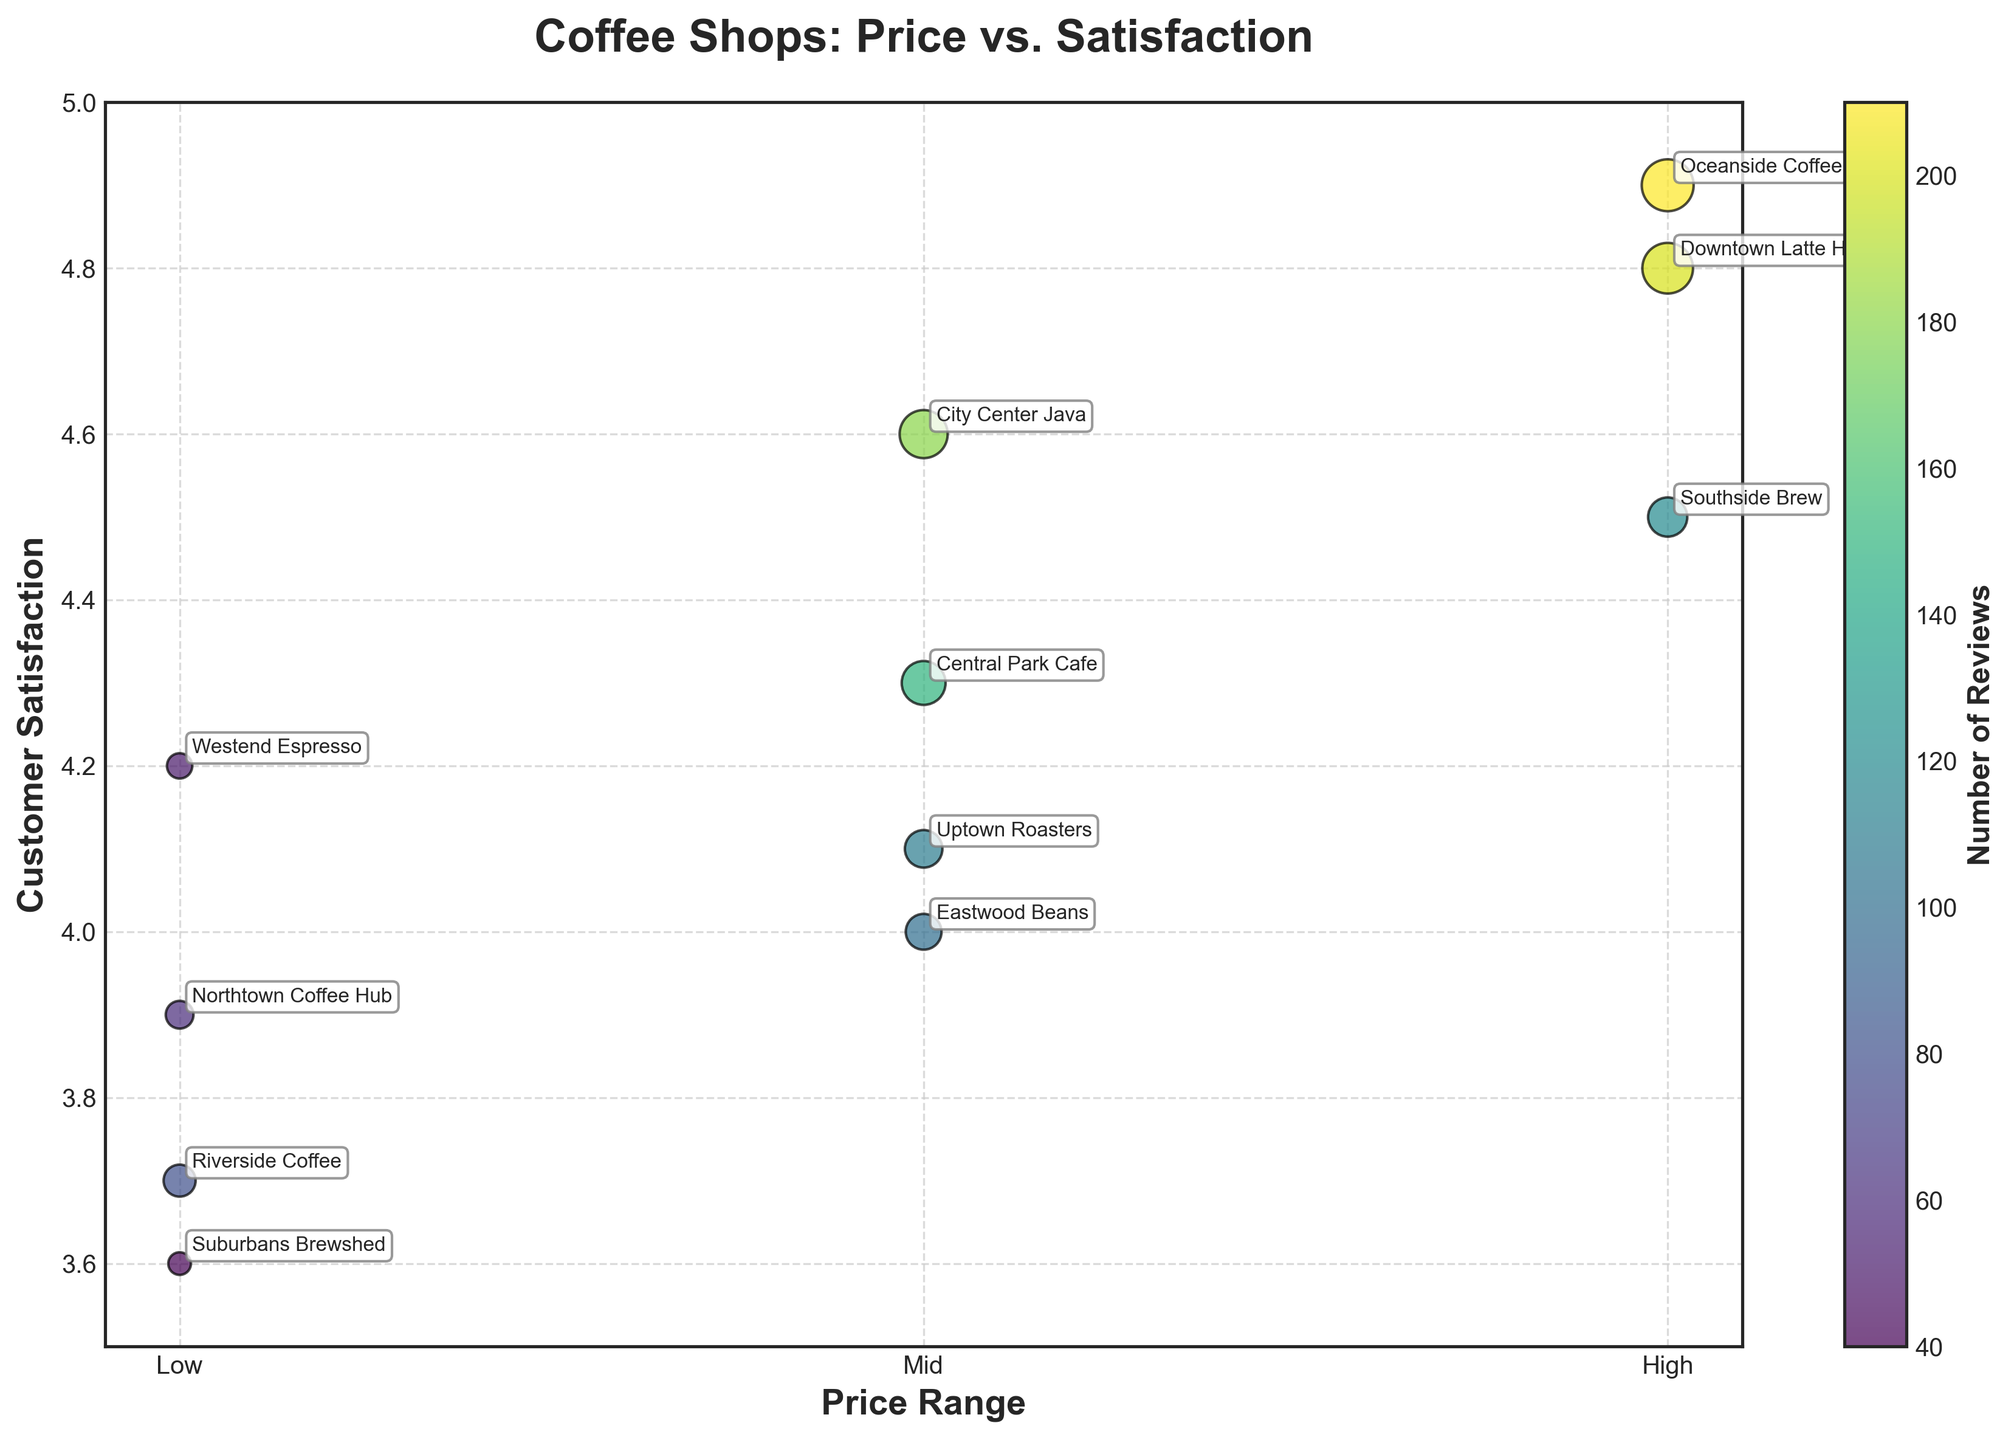What's the overall title of the figure? The overall title is located above the figure and summarizes what the figure represents. It reads "Coffee Shops: Price vs. Satisfaction".
Answer: Coffee Shops: Price vs. Satisfaction What does the x-axis label represent? The label of the x-axis is located along the horizontal axis and indicates the variable that is being measured on that axis. It represents the price range of the coffee shops.
Answer: Price Range What is the satisfaction level of 'Central Park Cafe'? Look for the bubble labeled 'Central Park Cafe' and check its position on the y-axis. The y-axis value for this point is approximately 4.3.
Answer: 4.3 Which coffee shop has the highest customer satisfaction? Identify the highest y-value on the plot and find the corresponding label. The bubble at the top of the chart is labeled 'Oceanside Coffee' with a customer satisfaction of 4.9.
Answer: Oceanside Coffee What is the average customer satisfaction of the coffee shops in the 'Mid' price range? First, locate the bubbles in the 'Mid' price range (x-axis value of 2). Their y-axis values are 4.3 (Central Park Cafe), 4.0 (Eastwood Beans), 4.6 (City Center Java), and 4.1 (Uptown Roasters). Calculate the average: (4.3 + 4.0 + 4.6 + 4.1) / 4 = 4.25.
Answer: 4.25 Which price range has the most reviews overall? Sum the size of bubbles (number of reviews) for each price category. For 'Low': 80 + 50 + 60 + 40 = 230 reviews. For 'Mid': 150 + 100 + 180 + 110 = 540 reviews. For 'High': 200 + 120 + 210 = 530 reviews. The 'Mid' price range has 540 reviews, which is the highest.
Answer: Mid How many coffee shops have a customer satisfaction higher than 4.5? Identify bubbles above the 4.5 mark on the y-axis. The coffee shops are Downtown Latte House, City Center Java, Oceanside Coffee, and Southside Brew. There are 4 bubbles above this mark.
Answer: 4 Which coffee shop is in the 'Low' price range and has the highest customer satisfaction? Focus on bubbles in the 'Low' price range (x-axis value of 1) and identify the one closest to the top. 'Westend Espresso' has the highest customer satisfaction at 4.2.
Answer: Westend Espresso Which coffee shop has the most reviews? Look for the largest bubble, which also correlates with a higher color intensity on the colorbar. The largest bubble corresponds to 'Oceanside Coffee'.
Answer: Oceanside Coffee 